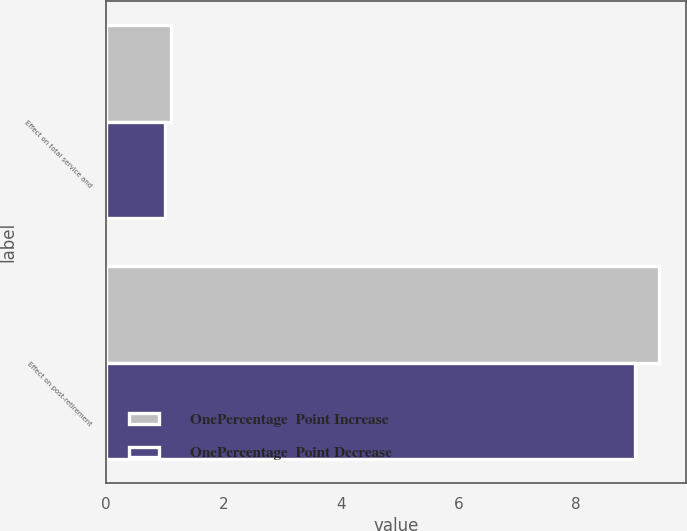Convert chart to OTSL. <chart><loc_0><loc_0><loc_500><loc_500><stacked_bar_chart><ecel><fcel>Effect on total service and<fcel>Effect on post-retirement<nl><fcel>OnePercentage  Point Increase<fcel>1.1<fcel>9.4<nl><fcel>OnePercentage  Point Decrease<fcel>1<fcel>9<nl></chart> 